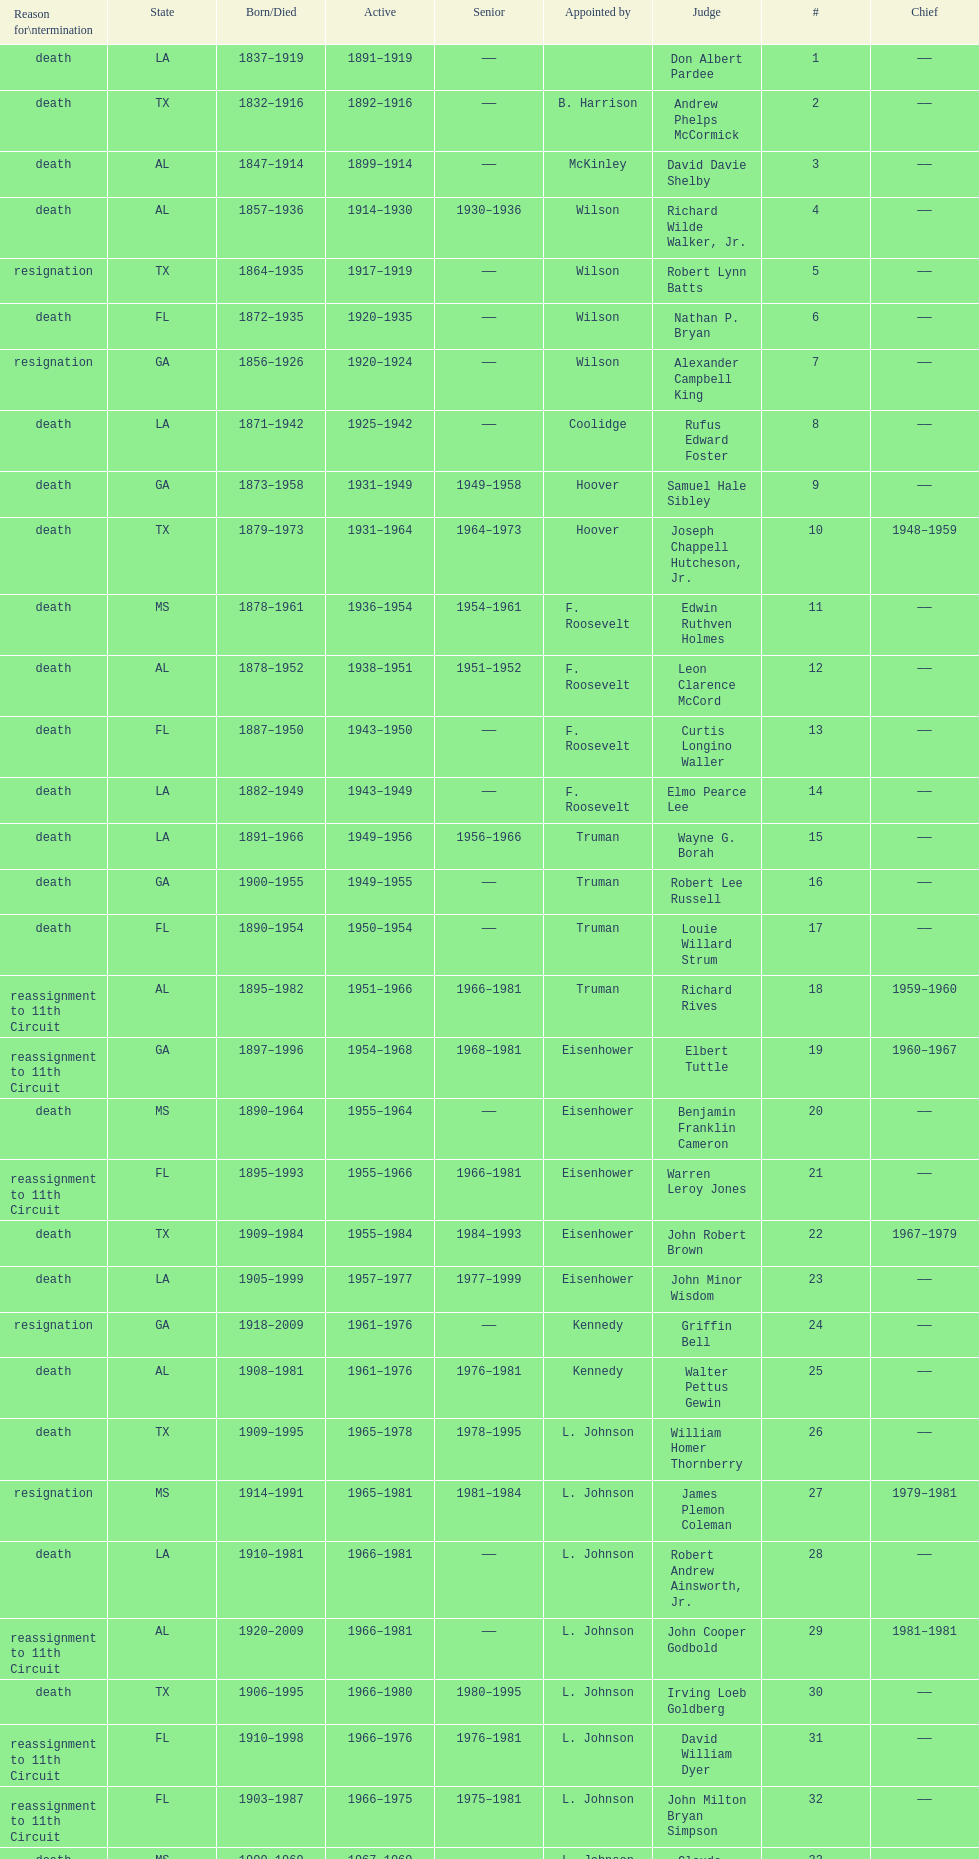Who was the first judge appointed from georgia? Alexander Campbell King. 